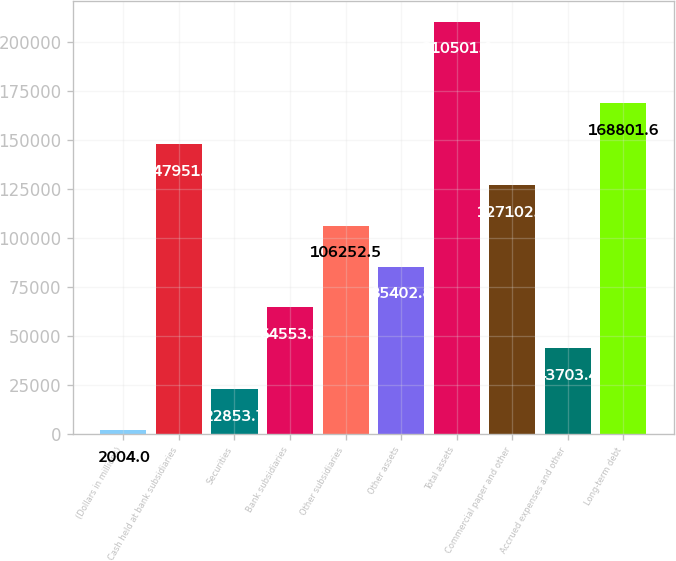Convert chart. <chart><loc_0><loc_0><loc_500><loc_500><bar_chart><fcel>(Dollars in millions)<fcel>Cash held at bank subsidiaries<fcel>Securities<fcel>Bank subsidiaries<fcel>Other subsidiaries<fcel>Other assets<fcel>Total assets<fcel>Commercial paper and other<fcel>Accrued expenses and other<fcel>Long-term debt<nl><fcel>2004<fcel>147952<fcel>22853.7<fcel>64553.1<fcel>106252<fcel>85402.8<fcel>210501<fcel>127102<fcel>43703.4<fcel>168802<nl></chart> 